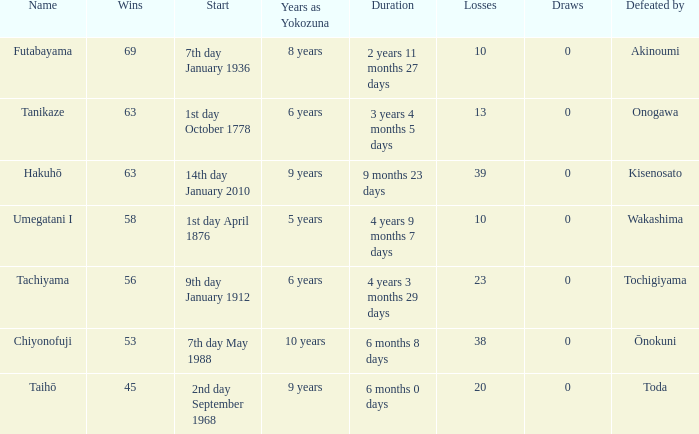What is the Duration for less than 53 consecutive wins? 6 months 0 days. 